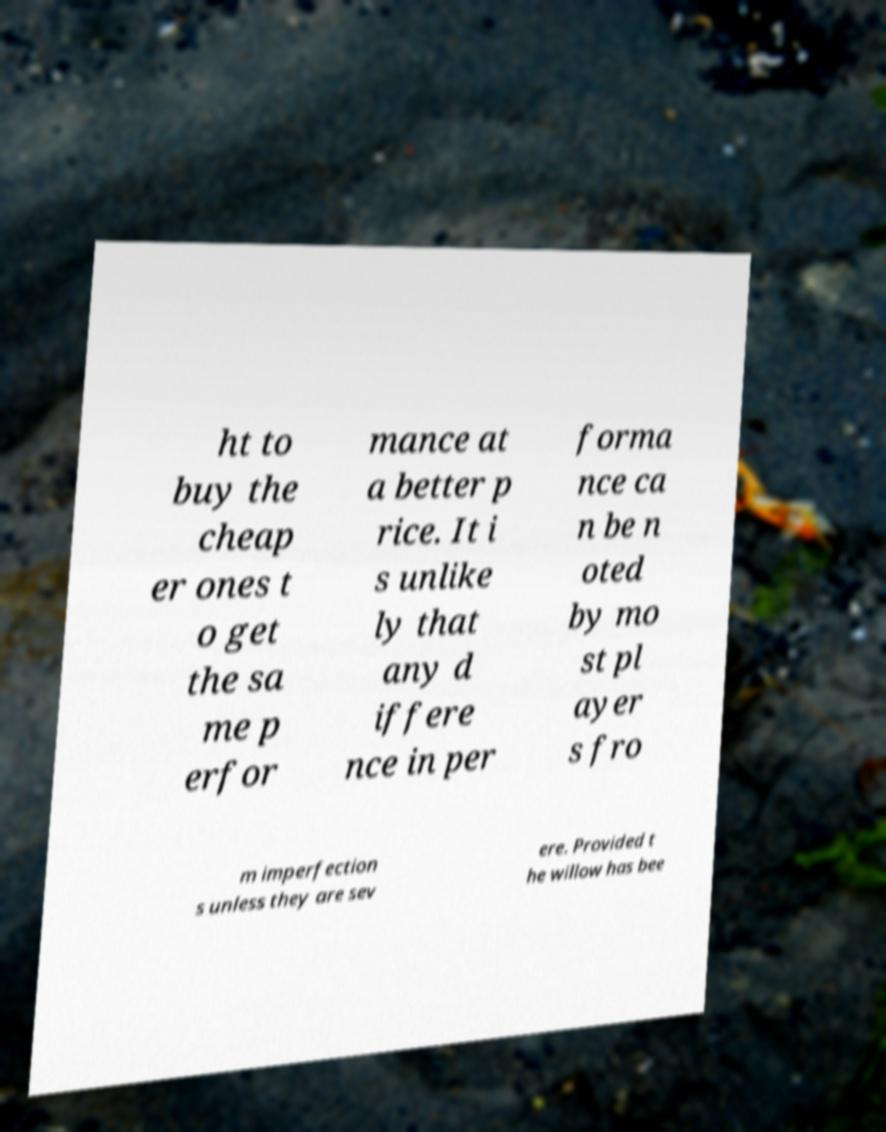Could you assist in decoding the text presented in this image and type it out clearly? ht to buy the cheap er ones t o get the sa me p erfor mance at a better p rice. It i s unlike ly that any d iffere nce in per forma nce ca n be n oted by mo st pl ayer s fro m imperfection s unless they are sev ere. Provided t he willow has bee 